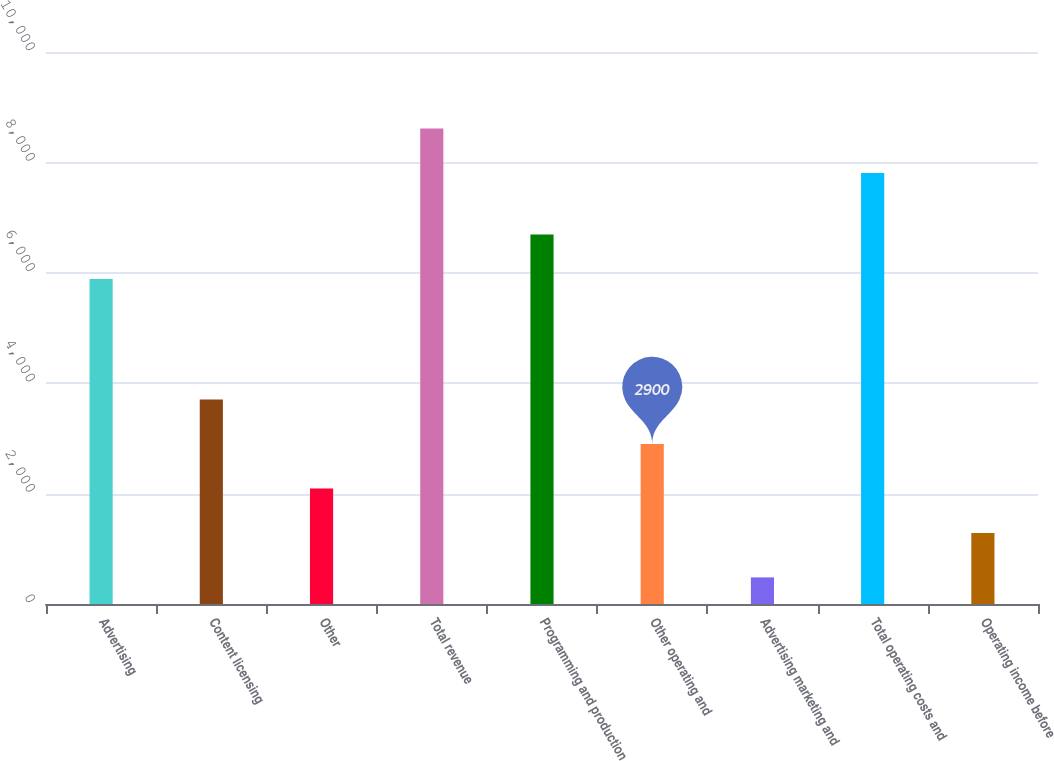Convert chart to OTSL. <chart><loc_0><loc_0><loc_500><loc_500><bar_chart><fcel>Advertising<fcel>Content licensing<fcel>Other<fcel>Total revenue<fcel>Programming and production<fcel>Other operating and<fcel>Advertising marketing and<fcel>Total operating costs and<fcel>Operating income before<nl><fcel>5888<fcel>3706<fcel>2094<fcel>8614<fcel>6694<fcel>2900<fcel>482<fcel>7808<fcel>1288<nl></chart> 